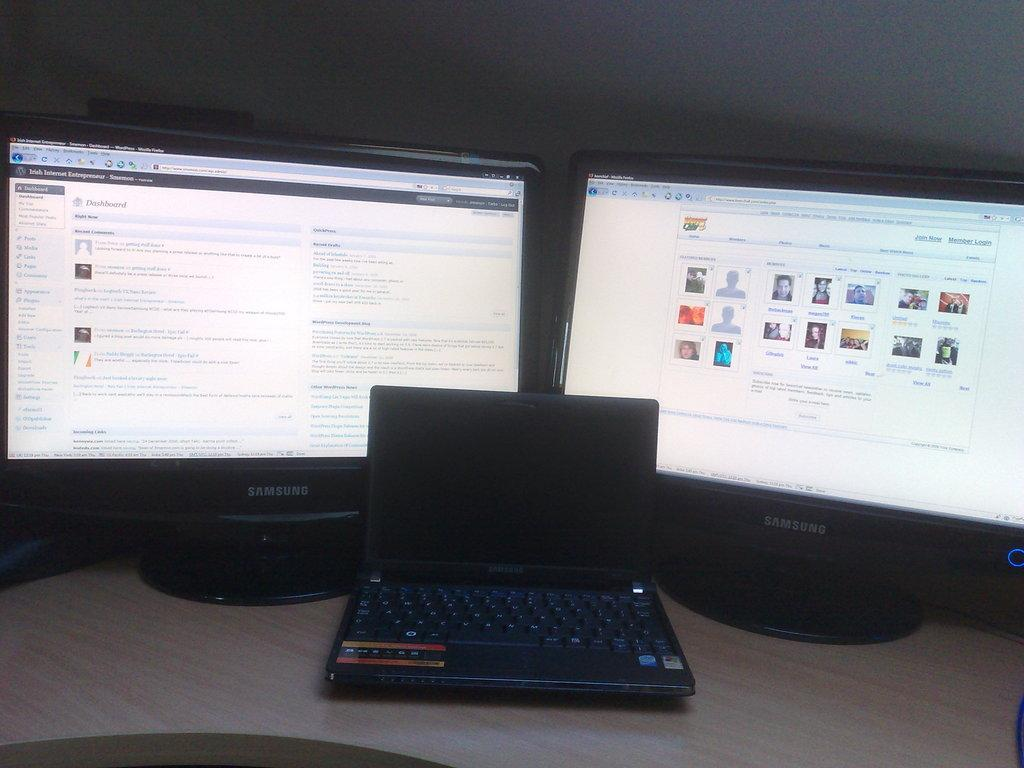Provide a one-sentence caption for the provided image. Two samsung computers turned on and laptop turned off. 